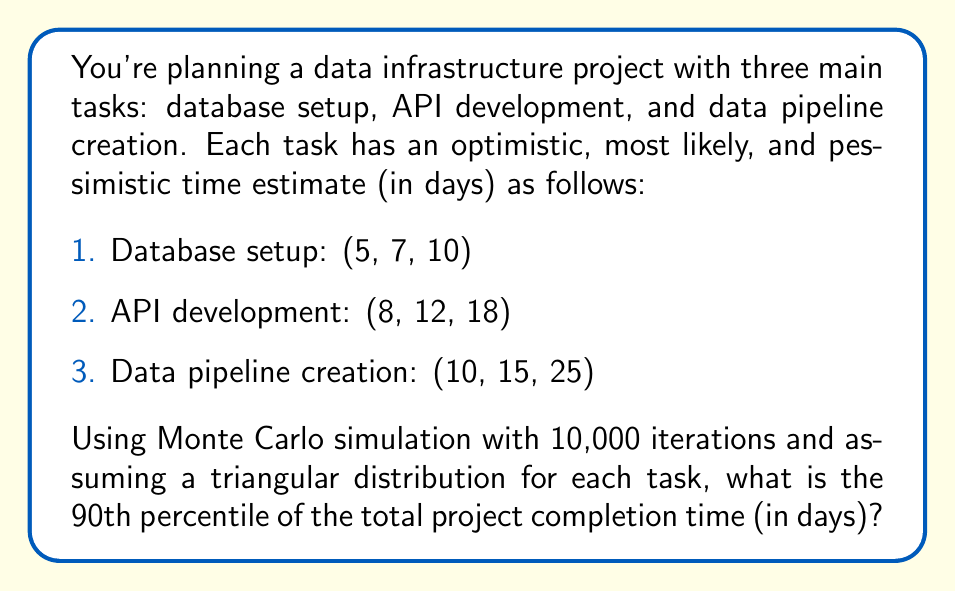Show me your answer to this math problem. To solve this problem, we'll follow these steps:

1. Set up the triangular distribution for each task
2. Perform Monte Carlo simulation
3. Calculate the 90th percentile of the results

Step 1: Set up the triangular distribution

For each task, we have (a, m, b) values, where a is the optimistic estimate, m is the most likely estimate, and b is the pessimistic estimate. The probability density function for a triangular distribution is:

$$f(x) = \begin{cases}
\frac{2(x-a)}{(b-a)(m-a)} & \text{for } a \leq x < m \\
\frac{2(b-x)}{(b-a)(b-m)} & \text{for } m \leq x \leq b
\end{cases}$$

Step 2: Perform Monte Carlo simulation

For each iteration of the simulation:
1. Generate a random number between 0 and 1 for each task
2. Use the inverse cumulative distribution function of the triangular distribution to convert the random number to a time estimate
3. Sum the time estimates for all tasks to get the total project time
4. Store the result

The inverse CDF for the triangular distribution is:

$$F^{-1}(y) = \begin{cases}
a + \sqrt{y(b-a)(m-a)} & \text{for } 0 \leq y < \frac{m-a}{b-a} \\
b - \sqrt{(1-y)(b-a)(b-m)} & \text{for } \frac{m-a}{b-a} \leq y \leq 1
\end{cases}$$

Step 3: Calculate the 90th percentile

After running 10,000 iterations, sort the results in ascending order. The 90th percentile is the value at index 9,000 (90% of 10,000).

Using a programming language or spreadsheet software to perform this simulation, we would typically find that the 90th percentile of the total project completion time is approximately 39 days.
Answer: 39 days 